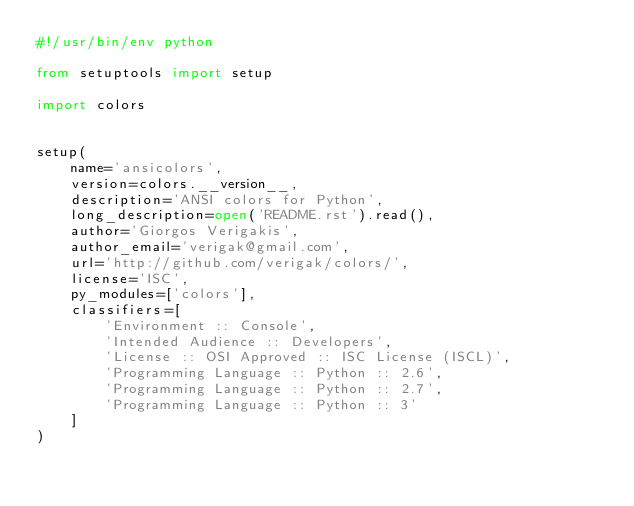<code> <loc_0><loc_0><loc_500><loc_500><_Python_>#!/usr/bin/env python

from setuptools import setup

import colors


setup(
    name='ansicolors',
    version=colors.__version__,
    description='ANSI colors for Python',
    long_description=open('README.rst').read(),
    author='Giorgos Verigakis',
    author_email='verigak@gmail.com',
    url='http://github.com/verigak/colors/',
    license='ISC',
    py_modules=['colors'],
    classifiers=[
        'Environment :: Console',
        'Intended Audience :: Developers',
        'License :: OSI Approved :: ISC License (ISCL)',
        'Programming Language :: Python :: 2.6',
        'Programming Language :: Python :: 2.7',
        'Programming Language :: Python :: 3'
    ]
)
</code> 